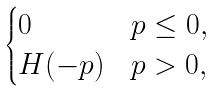Convert formula to latex. <formula><loc_0><loc_0><loc_500><loc_500>\begin{cases} 0 \quad & p \leq 0 , \\ H ( - p ) & p > 0 , \end{cases}</formula> 